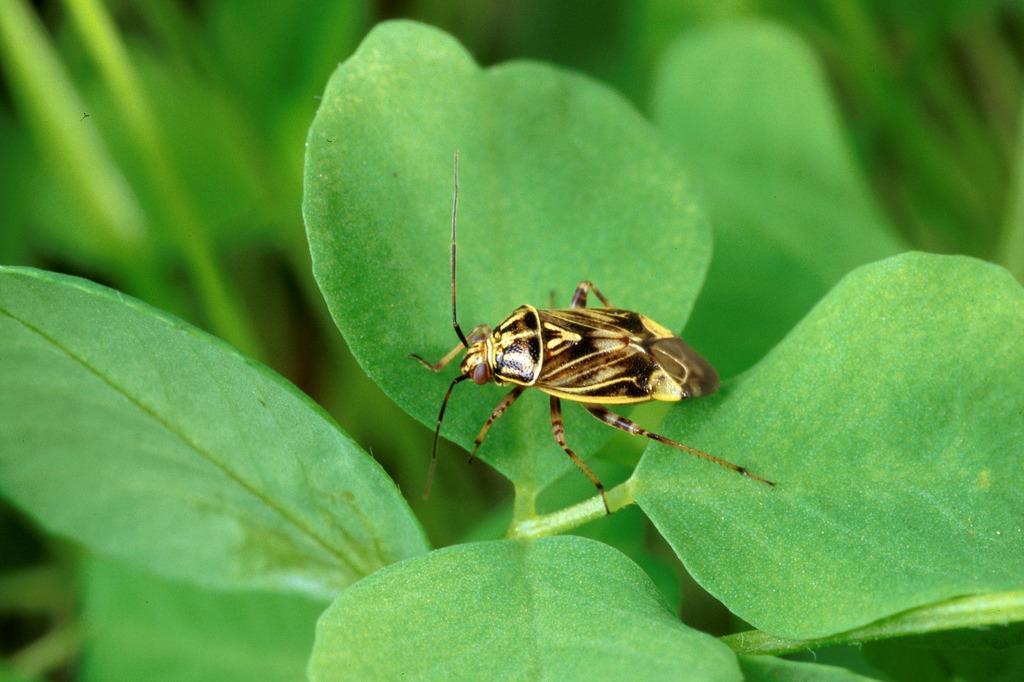In one or two sentences, can you explain what this image depicts? In the center of the image we can see insect on the plant. 